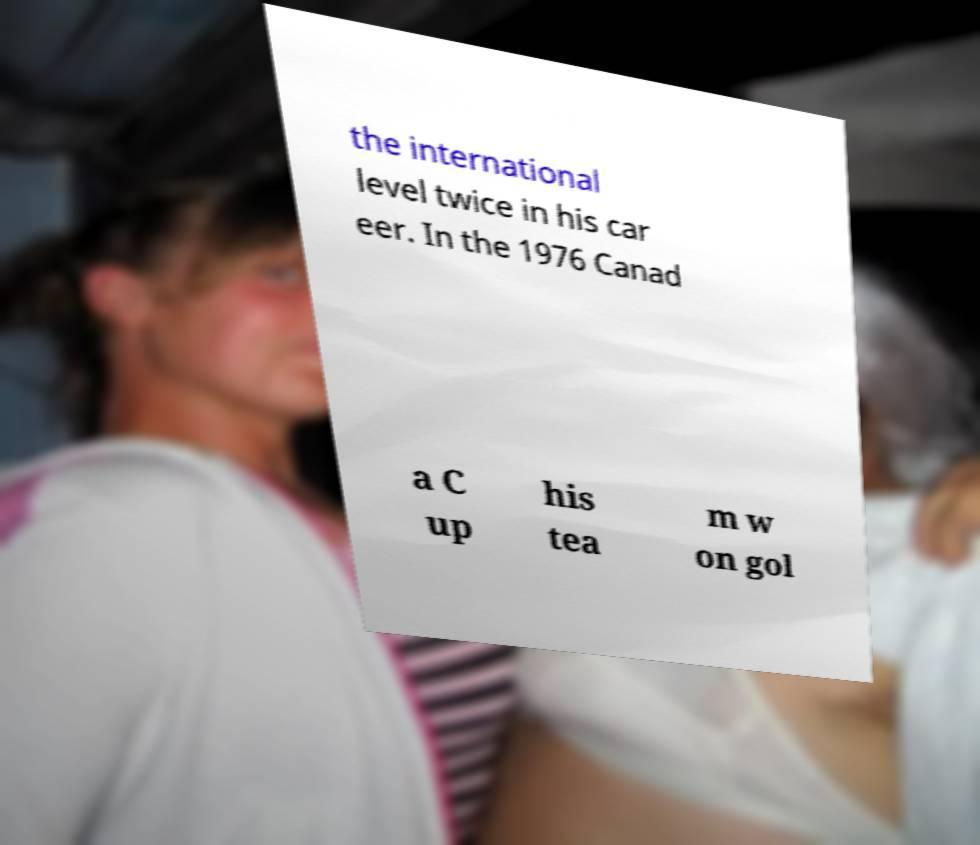There's text embedded in this image that I need extracted. Can you transcribe it verbatim? the international level twice in his car eer. In the 1976 Canad a C up his tea m w on gol 